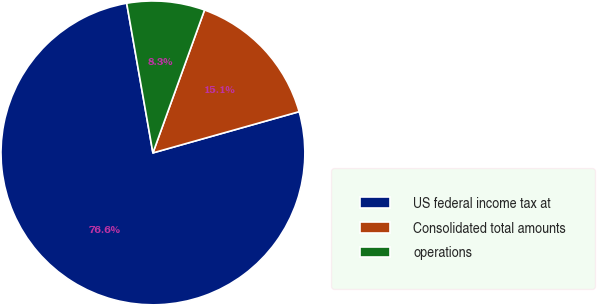<chart> <loc_0><loc_0><loc_500><loc_500><pie_chart><fcel>US federal income tax at<fcel>Consolidated total amounts<fcel>operations<nl><fcel>76.61%<fcel>15.11%<fcel>8.28%<nl></chart> 